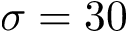Convert formula to latex. <formula><loc_0><loc_0><loc_500><loc_500>\sigma = 3 0</formula> 